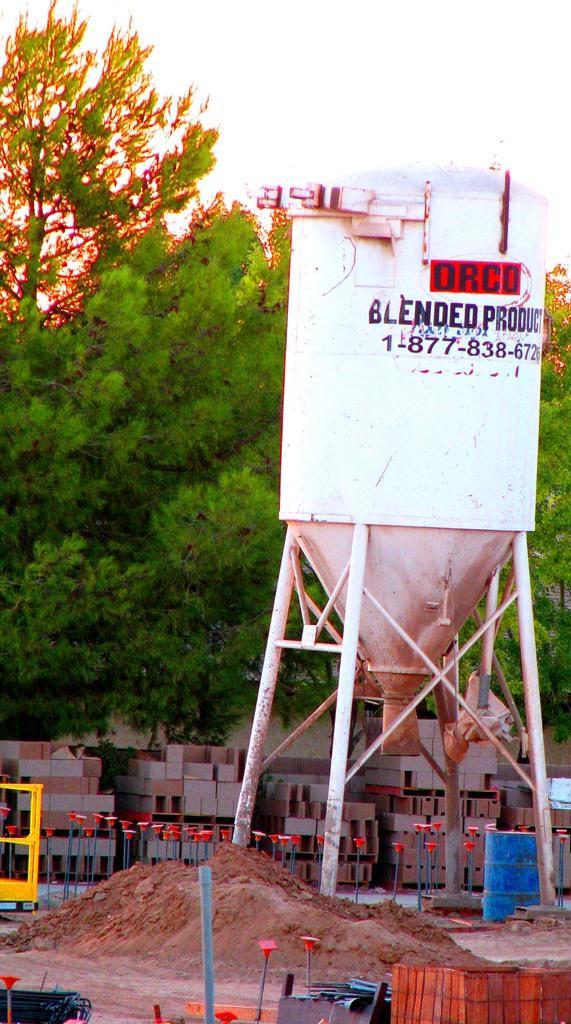Describe this image in one or two sentences. In this image I can see a machine in white color, background I can see trees in green color, few blocks and the sky is in white color. 